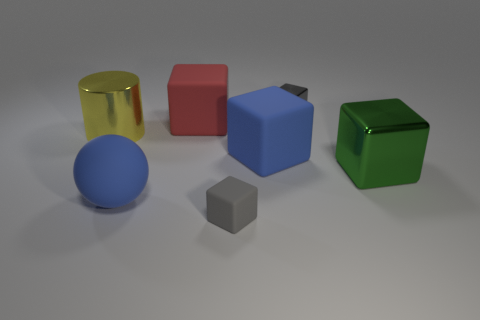Does the ball have the same color as the large cylinder?
Ensure brevity in your answer.  No. There is a metallic object to the left of the tiny cube behind the big matte sphere; what shape is it?
Give a very brief answer. Cylinder. What shape is the yellow object that is the same material as the green block?
Ensure brevity in your answer.  Cylinder. How many other objects are there of the same shape as the big green shiny object?
Offer a terse response. 4. There is a gray object that is behind the green metal object; is its size the same as the small matte thing?
Offer a very short reply. Yes. Is the number of gray metallic blocks that are behind the tiny gray rubber block greater than the number of large green matte cylinders?
Provide a succinct answer. Yes. There is a blue rubber thing that is to the right of the small gray rubber thing; how many big blocks are in front of it?
Ensure brevity in your answer.  1. Is the number of big rubber things that are behind the green shiny object less than the number of big yellow metal cylinders?
Make the answer very short. No. There is a big object that is to the right of the gray object that is behind the yellow metallic cylinder; is there a large cylinder in front of it?
Your answer should be compact. No. Does the large green thing have the same material as the big object left of the large rubber sphere?
Give a very brief answer. Yes. 